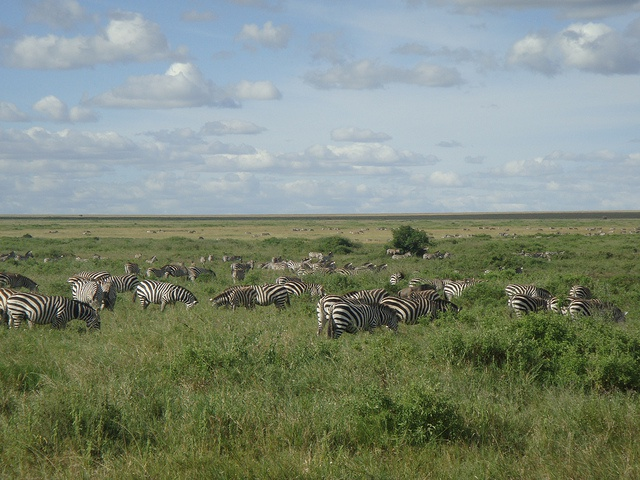Describe the objects in this image and their specific colors. I can see zebra in darkgray, gray, darkgreen, and black tones, zebra in darkgray, black, gray, and darkgreen tones, zebra in darkgray, black, gray, and darkgreen tones, zebra in darkgray, black, gray, olive, and ivory tones, and zebra in darkgray, black, gray, and darkgreen tones in this image. 